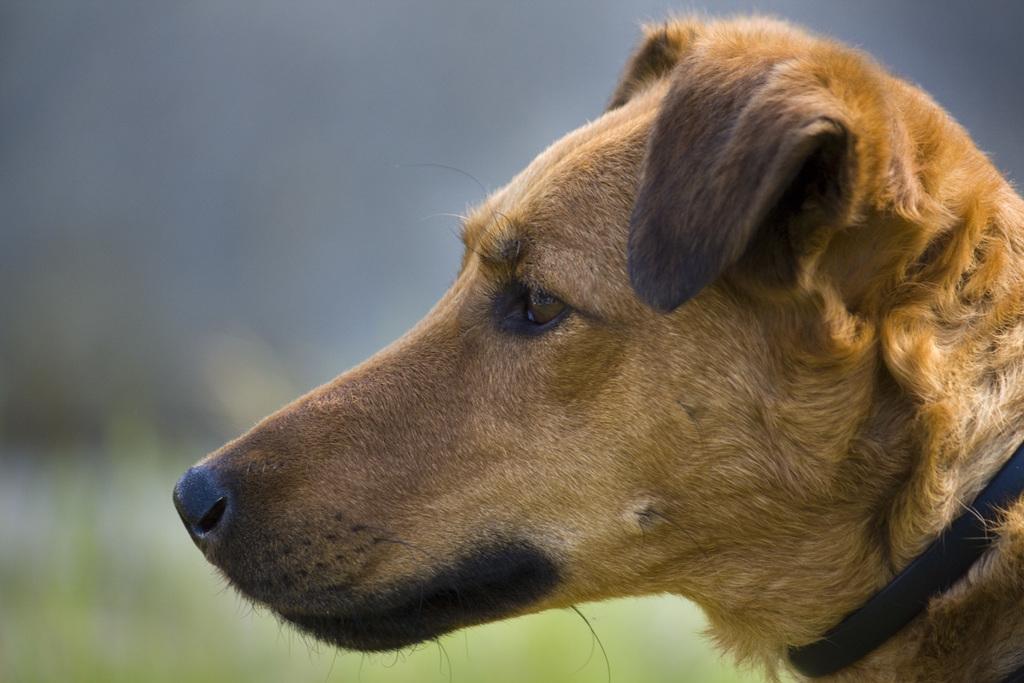Could you give a brief overview of what you see in this image? In this image I can see a dog which is in brown and black color. Background is blurred. 